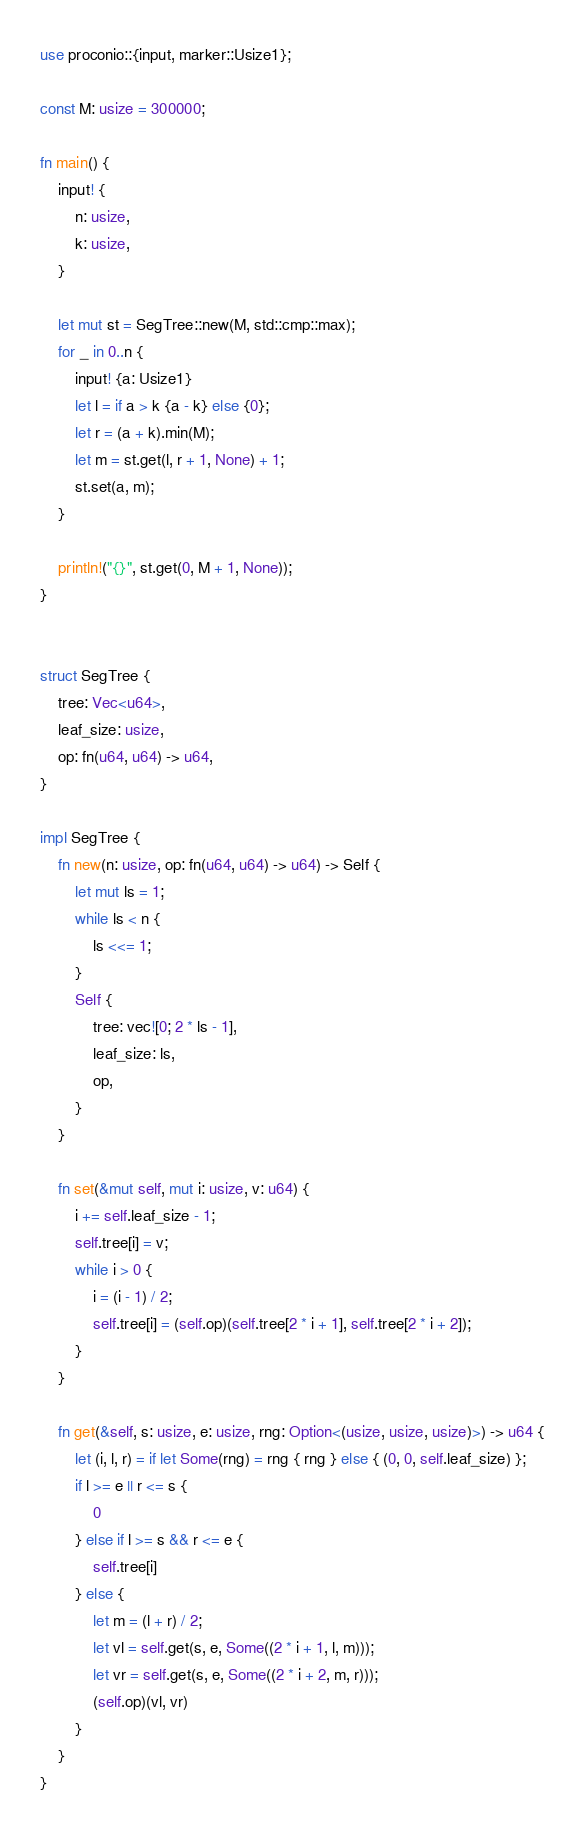<code> <loc_0><loc_0><loc_500><loc_500><_Rust_>use proconio::{input, marker::Usize1};

const M: usize = 300000;

fn main() {
    input! {
        n: usize,
        k: usize,
    }

    let mut st = SegTree::new(M, std::cmp::max);
    for _ in 0..n {
        input! {a: Usize1}
        let l = if a > k {a - k} else {0};
        let r = (a + k).min(M);
        let m = st.get(l, r + 1, None) + 1;
        st.set(a, m);
    }

    println!("{}", st.get(0, M + 1, None));
}


struct SegTree {
    tree: Vec<u64>,
    leaf_size: usize,
    op: fn(u64, u64) -> u64,
}

impl SegTree {
    fn new(n: usize, op: fn(u64, u64) -> u64) -> Self {
        let mut ls = 1;
        while ls < n {
            ls <<= 1;
        }
        Self {
            tree: vec![0; 2 * ls - 1],
            leaf_size: ls,
            op,
        }
    }

    fn set(&mut self, mut i: usize, v: u64) {
        i += self.leaf_size - 1;
        self.tree[i] = v;
        while i > 0 {
            i = (i - 1) / 2;
            self.tree[i] = (self.op)(self.tree[2 * i + 1], self.tree[2 * i + 2]);
        }
    }

    fn get(&self, s: usize, e: usize, rng: Option<(usize, usize, usize)>) -> u64 {
        let (i, l, r) = if let Some(rng) = rng { rng } else { (0, 0, self.leaf_size) };
        if l >= e || r <= s {
            0
        } else if l >= s && r <= e {
            self.tree[i]
        } else {
            let m = (l + r) / 2;
            let vl = self.get(s, e, Some((2 * i + 1, l, m)));
            let vr = self.get(s, e, Some((2 * i + 2, m, r)));
            (self.op)(vl, vr)
        }
    }
}
</code> 